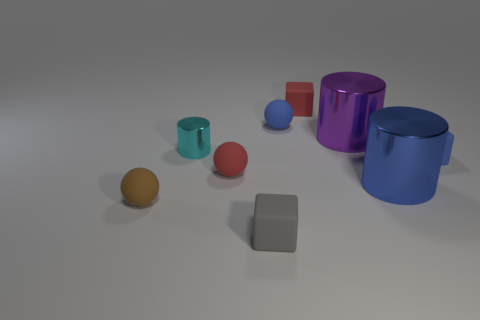What number of small things are to the right of the tiny brown matte object and in front of the big blue object?
Your response must be concise. 1. What number of spheres are gray matte things or big yellow things?
Offer a terse response. 0. Are any matte things visible?
Keep it short and to the point. Yes. What number of other objects are there of the same material as the red block?
Your answer should be very brief. 5. There is a gray thing that is the same size as the blue rubber ball; what material is it?
Your answer should be compact. Rubber. Does the large metal thing that is to the right of the purple cylinder have the same shape as the purple thing?
Provide a succinct answer. Yes. How many objects are either rubber things on the right side of the small red cube or red rubber spheres?
Your answer should be compact. 2. There is a brown matte thing that is the same size as the cyan metal thing; what is its shape?
Your response must be concise. Sphere. There is a rubber cube that is on the right side of the blue metallic cylinder; is it the same size as the blue thing that is to the left of the small red block?
Your response must be concise. Yes. The tiny object that is made of the same material as the large blue cylinder is what color?
Your answer should be very brief. Cyan. 